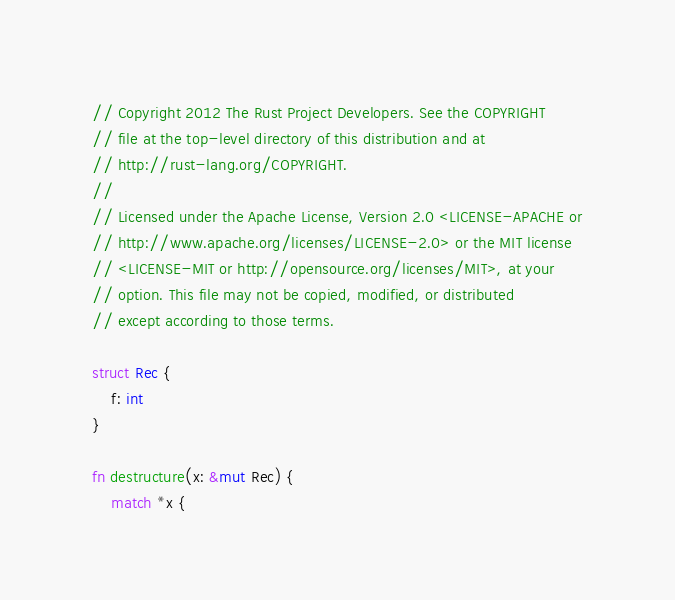Convert code to text. <code><loc_0><loc_0><loc_500><loc_500><_Rust_>// Copyright 2012 The Rust Project Developers. See the COPYRIGHT
// file at the top-level directory of this distribution and at
// http://rust-lang.org/COPYRIGHT.
//
// Licensed under the Apache License, Version 2.0 <LICENSE-APACHE or
// http://www.apache.org/licenses/LICENSE-2.0> or the MIT license
// <LICENSE-MIT or http://opensource.org/licenses/MIT>, at your
// option. This file may not be copied, modified, or distributed
// except according to those terms.

struct Rec {
    f: int
}

fn destructure(x: &mut Rec) {
    match *x {</code> 